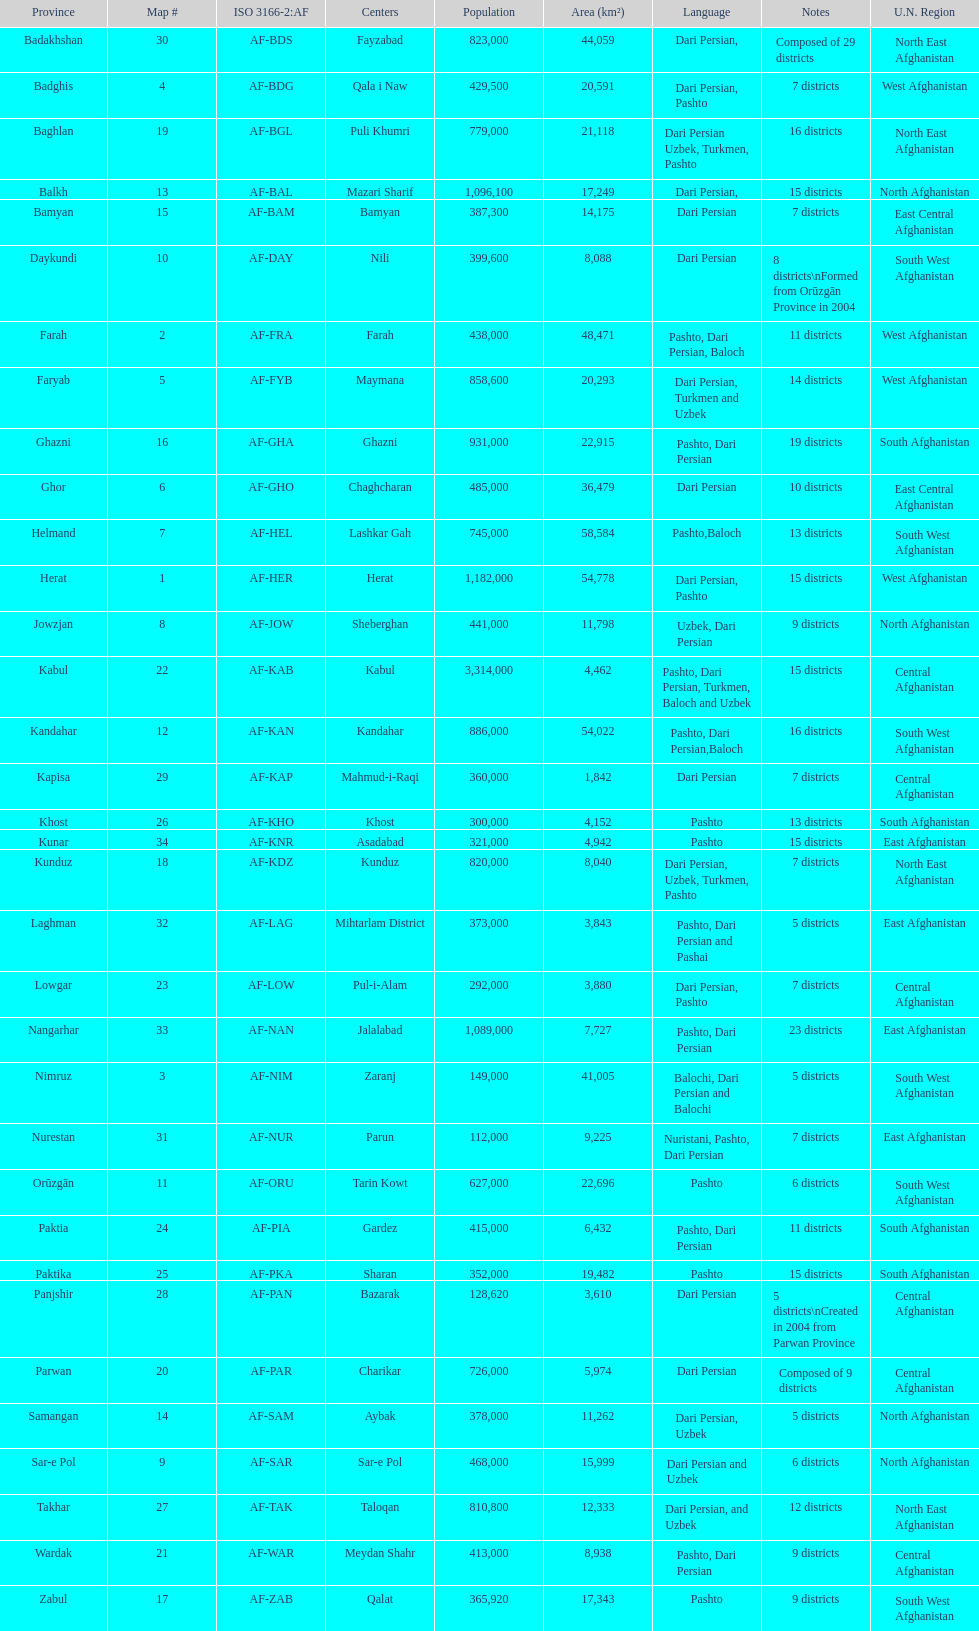Could you enumerate the languages used by the population of 1,182,000 in herat? Dari Persian, Pashto. 